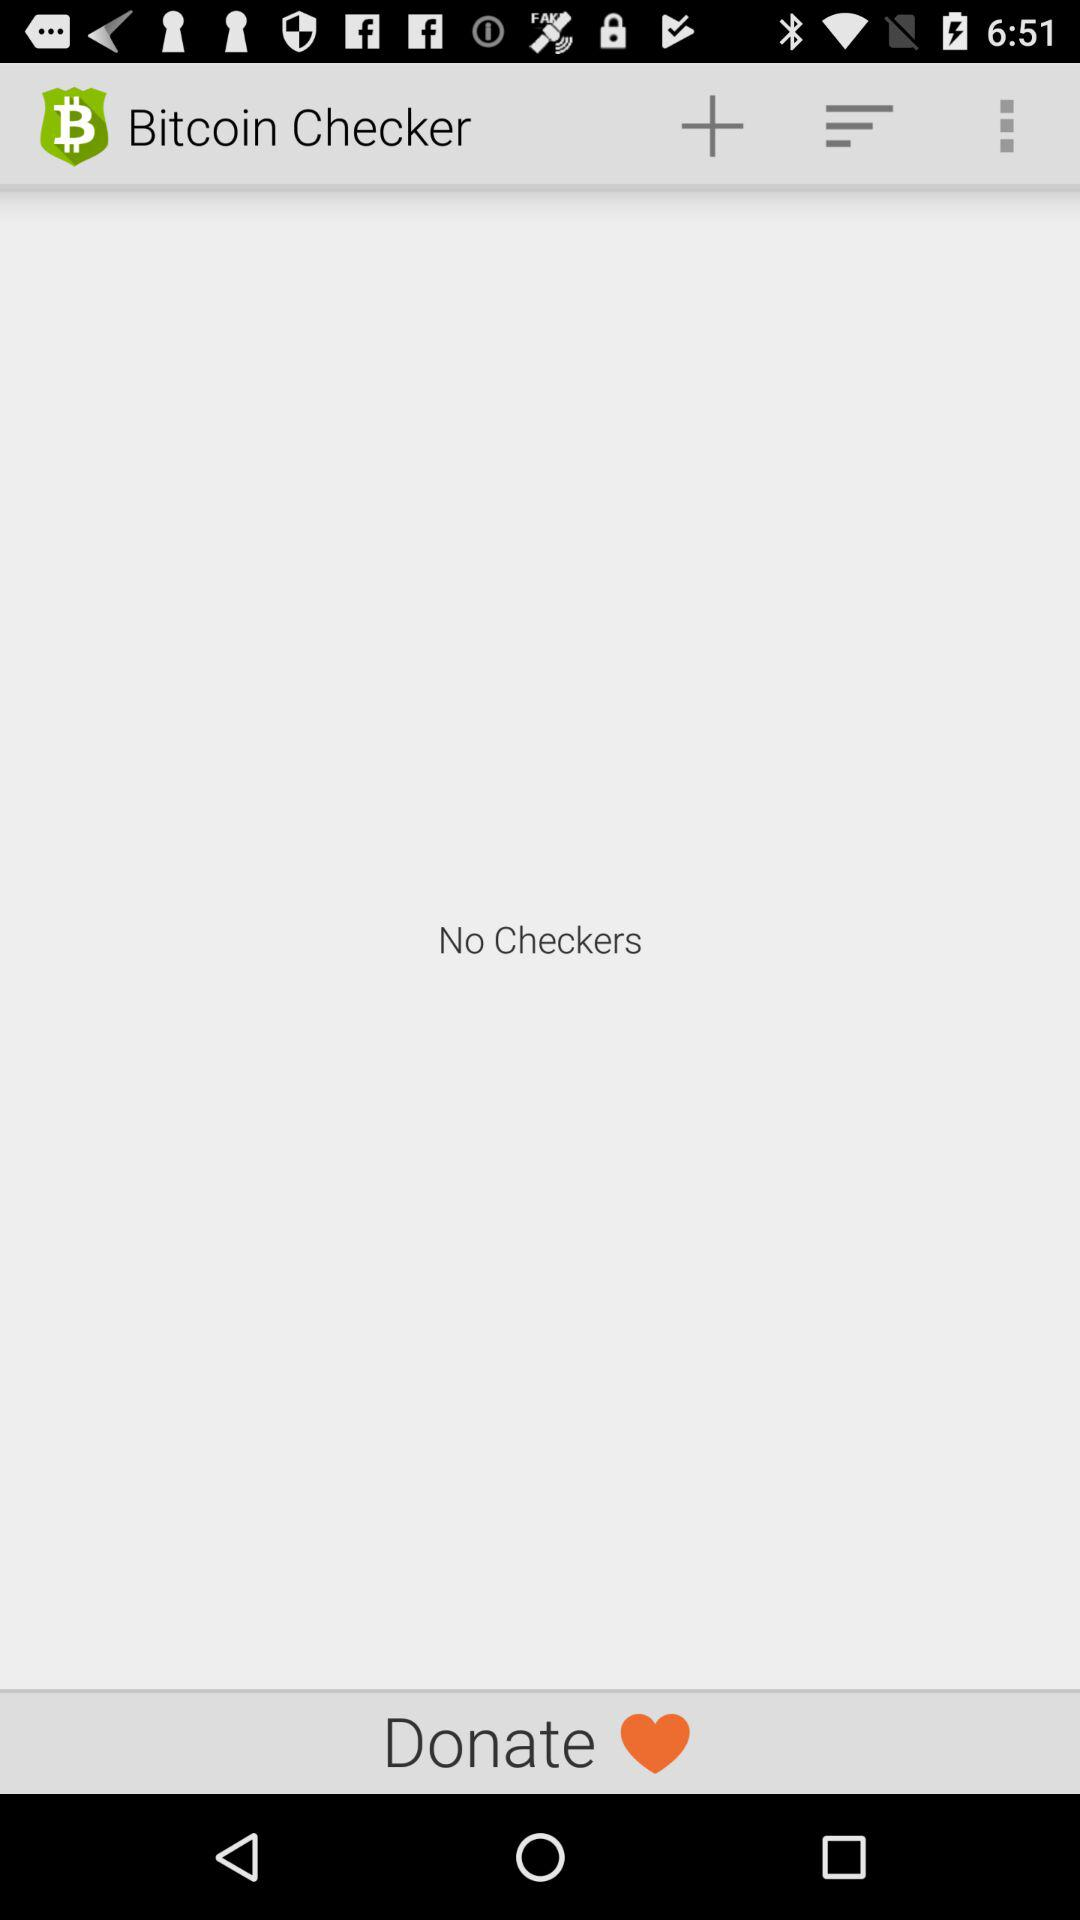What is the application name? The application name is "Bitcoin Checker". 